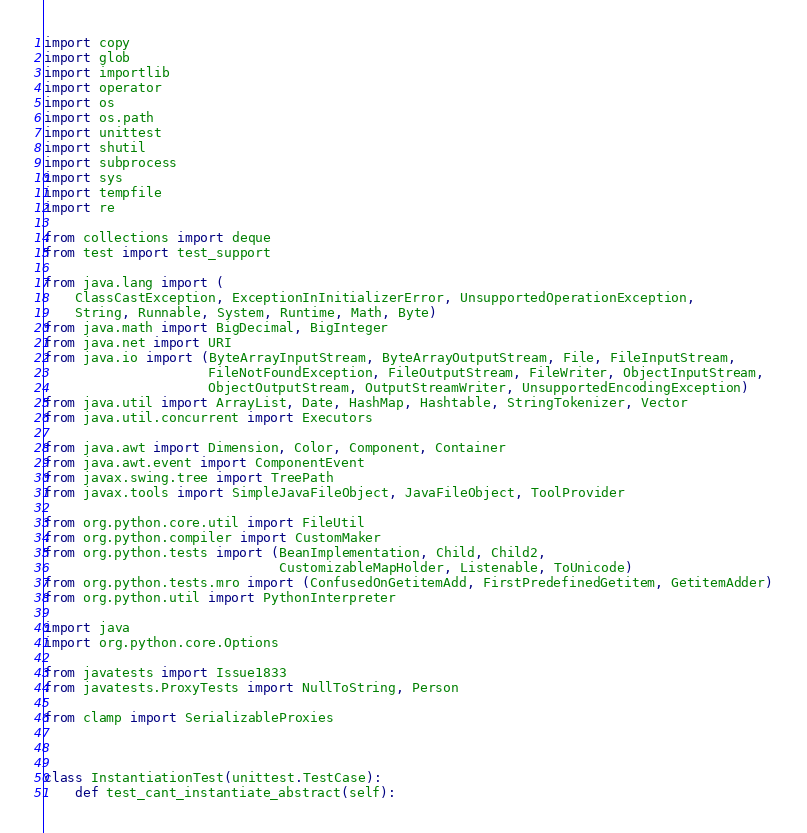<code> <loc_0><loc_0><loc_500><loc_500><_Python_>import copy
import glob
import importlib
import operator
import os
import os.path
import unittest
import shutil
import subprocess
import sys
import tempfile
import re

from collections import deque
from test import test_support

from java.lang import (
    ClassCastException, ExceptionInInitializerError, UnsupportedOperationException,
    String, Runnable, System, Runtime, Math, Byte)
from java.math import BigDecimal, BigInteger
from java.net import URI
from java.io import (ByteArrayInputStream, ByteArrayOutputStream, File, FileInputStream,
                     FileNotFoundException, FileOutputStream, FileWriter, ObjectInputStream,
                     ObjectOutputStream, OutputStreamWriter, UnsupportedEncodingException)
from java.util import ArrayList, Date, HashMap, Hashtable, StringTokenizer, Vector
from java.util.concurrent import Executors

from java.awt import Dimension, Color, Component, Container
from java.awt.event import ComponentEvent
from javax.swing.tree import TreePath
from javax.tools import SimpleJavaFileObject, JavaFileObject, ToolProvider

from org.python.core.util import FileUtil
from org.python.compiler import CustomMaker
from org.python.tests import (BeanImplementation, Child, Child2,
                              CustomizableMapHolder, Listenable, ToUnicode)
from org.python.tests.mro import (ConfusedOnGetitemAdd, FirstPredefinedGetitem, GetitemAdder)
from org.python.util import PythonInterpreter

import java
import org.python.core.Options

from javatests import Issue1833
from javatests.ProxyTests import NullToString, Person

from clamp import SerializableProxies



class InstantiationTest(unittest.TestCase):
    def test_cant_instantiate_abstract(self):</code> 